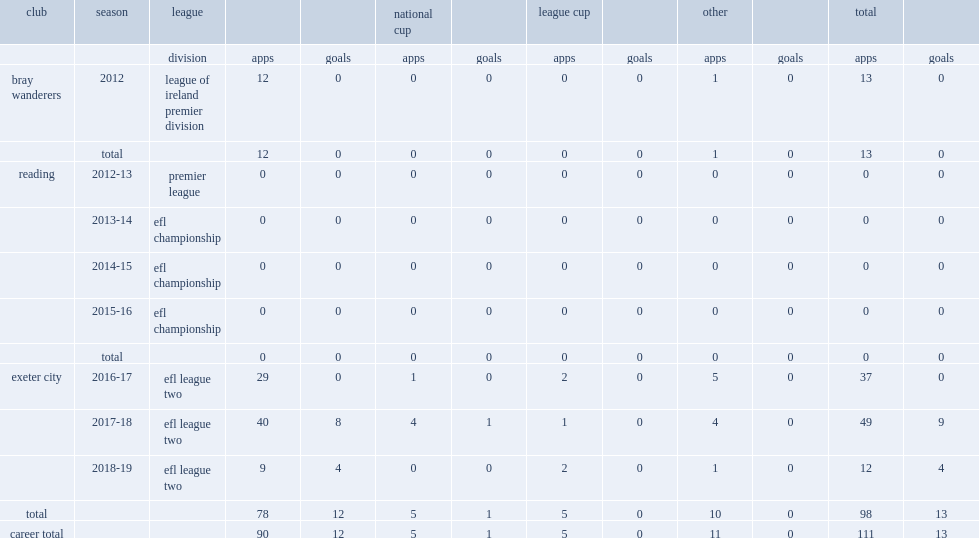In 2012, which league did sweeney join side bray wanderers? League of ireland premier division. 